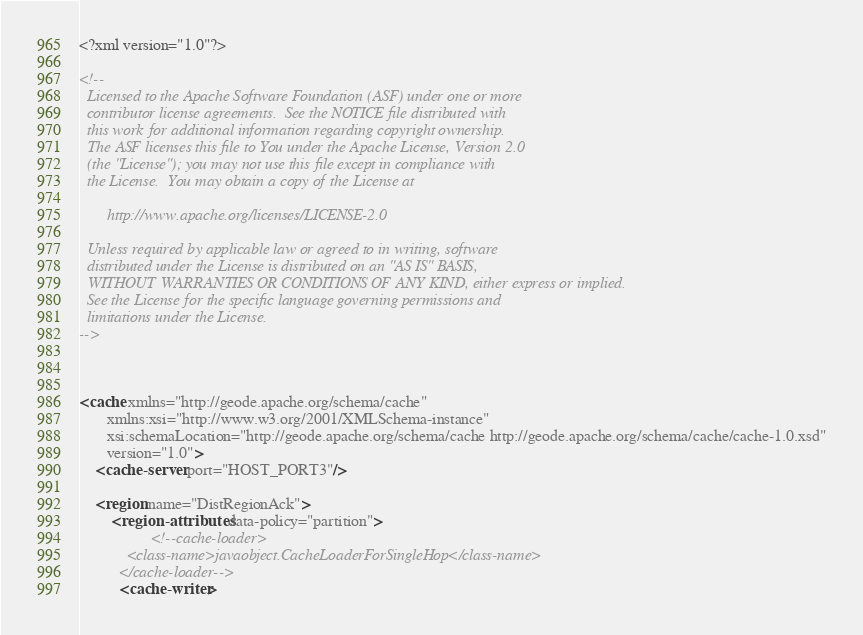<code> <loc_0><loc_0><loc_500><loc_500><_XML_><?xml version="1.0"?>

<!--
  Licensed to the Apache Software Foundation (ASF) under one or more
  contributor license agreements.  See the NOTICE file distributed with
  this work for additional information regarding copyright ownership.
  The ASF licenses this file to You under the Apache License, Version 2.0
  (the "License"); you may not use this file except in compliance with
  the License.  You may obtain a copy of the License at
  
       http://www.apache.org/licenses/LICENSE-2.0
  
  Unless required by applicable law or agreed to in writing, software
  distributed under the License is distributed on an "AS IS" BASIS,
  WITHOUT WARRANTIES OR CONDITIONS OF ANY KIND, either express or implied.
  See the License for the specific language governing permissions and
  limitations under the License.
-->



<cache xmlns="http://geode.apache.org/schema/cache"
       xmlns:xsi="http://www.w3.org/2001/XMLSchema-instance"
       xsi:schemaLocation="http://geode.apache.org/schema/cache http://geode.apache.org/schema/cache/cache-1.0.xsd"
       version="1.0">
	<cache-server port="HOST_PORT3"/>

	<region name="DistRegionAck">
		<region-attributes data-policy="partition">
				  <!--cache-loader>
            <class-name>javaobject.CacheLoaderForSingleHop</class-name>
          </cache-loader-->
          <cache-writer></code> 